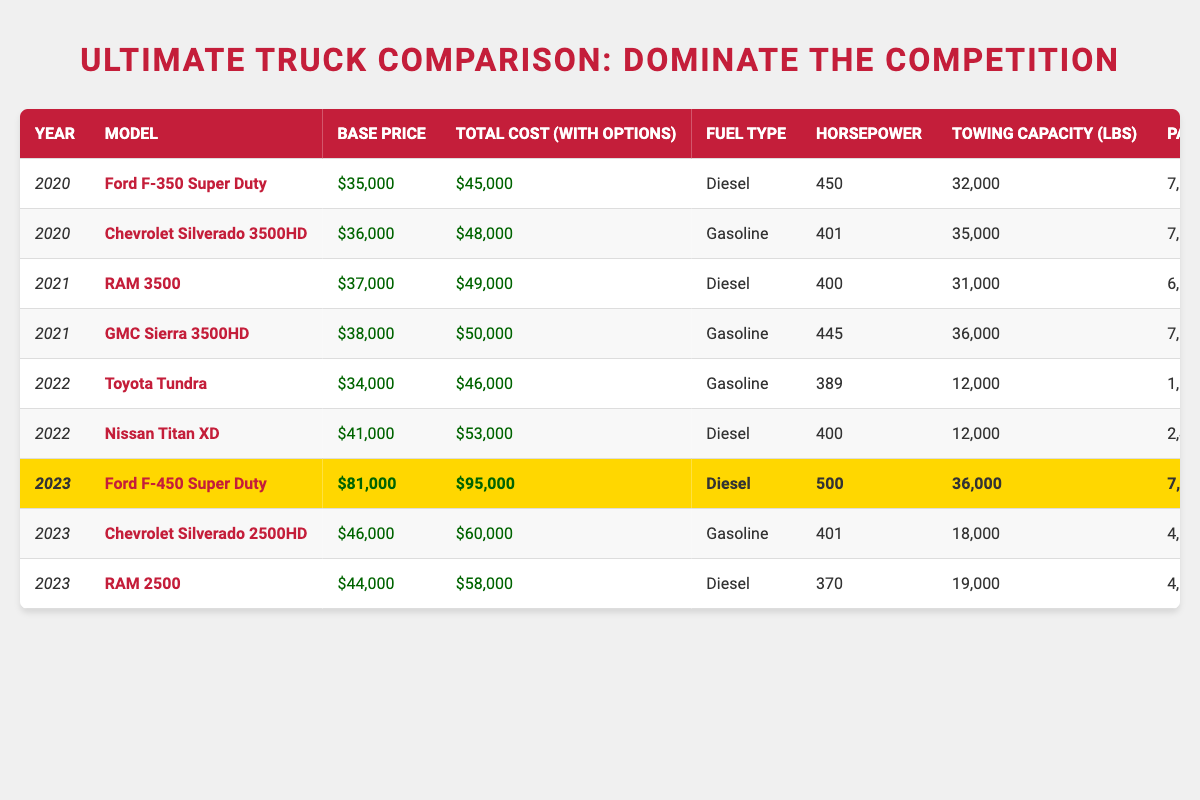What is the total cost for the Chevrolet Silverado 3500HD model in 2020? The total cost for the Chevrolet Silverado 3500HD model in the year 2020 can be found in the table, listed under "Total Cost (with Options)" for that model. It shows $48,000.
Answer: $48,000 Which model has the highest towing capacity in 2021? In 2021, the model with the highest towing capacity is the GMC Sierra 3500HD, which shows a towing capacity of 36,000 lbs in the table.
Answer: GMC Sierra 3500HD What is the difference in base price between the RAM 2500 and the Ford F-450 Super Duty in 2023? To find the difference, first locate the base prices: RAM 2500 is $44,000 and Ford F-450 Super Duty is $81,000. Then, compute the difference: $81,000 - $44,000 = $37,000.
Answer: $37,000 Is the RAM 3500 equipped with a gasoline engine in 2021? According to the table, the RAM 3500 in 2021 lists "Diesel" as its fuel type, so it is not equipped with a gasoline engine.
Answer: No What is the average total cost of all models for the year 2022? First, locate the total costs for all models in 2022. The total costs are $46,000 (Toyota Tundra) and $53,000 (Nissan Titan XD). Sum them: $46,000 + $53,000 = $99,000. Then, divide by the number of models (2): $99,000 / 2 = $49,500.
Answer: $49,500 Which model in 2023 has the most horsepower? In 2023, the Ford F-450 Super Duty has the highest horsepower of 500 according to the table, compared to the RAM 2500's 370 and Chevrolet Silverado 2500HD's 401.
Answer: Ford F-450 Super Duty What is the total payload capacity of both the Toyota Tundra and Nissan Titan XD combined in 2022? The payload capacity of the Toyota Tundra is 1,600 lbs, and for the Nissan Titan XD, it is 2,400 lbs. Adding them together: 1,600 + 2,400 = 4,000 lbs.
Answer: 4,000 lbs Is it true that the base price of the Chevrolet Silverado 2500HD in 2023 is below $50,000? The table shows the base price of the Chevrolet Silverado 2500HD in 2023 is $46,000, which is indeed below $50,000.
Answer: Yes What is the average horsepower of all models for the year 2021? The horsepower for models in 2021 is 400 (RAM 3500) and 445 (GMC Sierra 3500HD). Summing these gives 400 + 445 = 845. Dividing by the number of models (2) gives: 845 / 2 = 422.5.
Answer: 422.5 Which model has the lowest payload capacity in 2022? Reviewing the payload capacities in 2022, the Toyota Tundra has the lowest at 1,600 lbs compared to 2,400 lbs from the Nissan Titan XD.
Answer: Toyota Tundra 